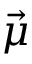Convert formula to latex. <formula><loc_0><loc_0><loc_500><loc_500>\vec { \mu }</formula> 